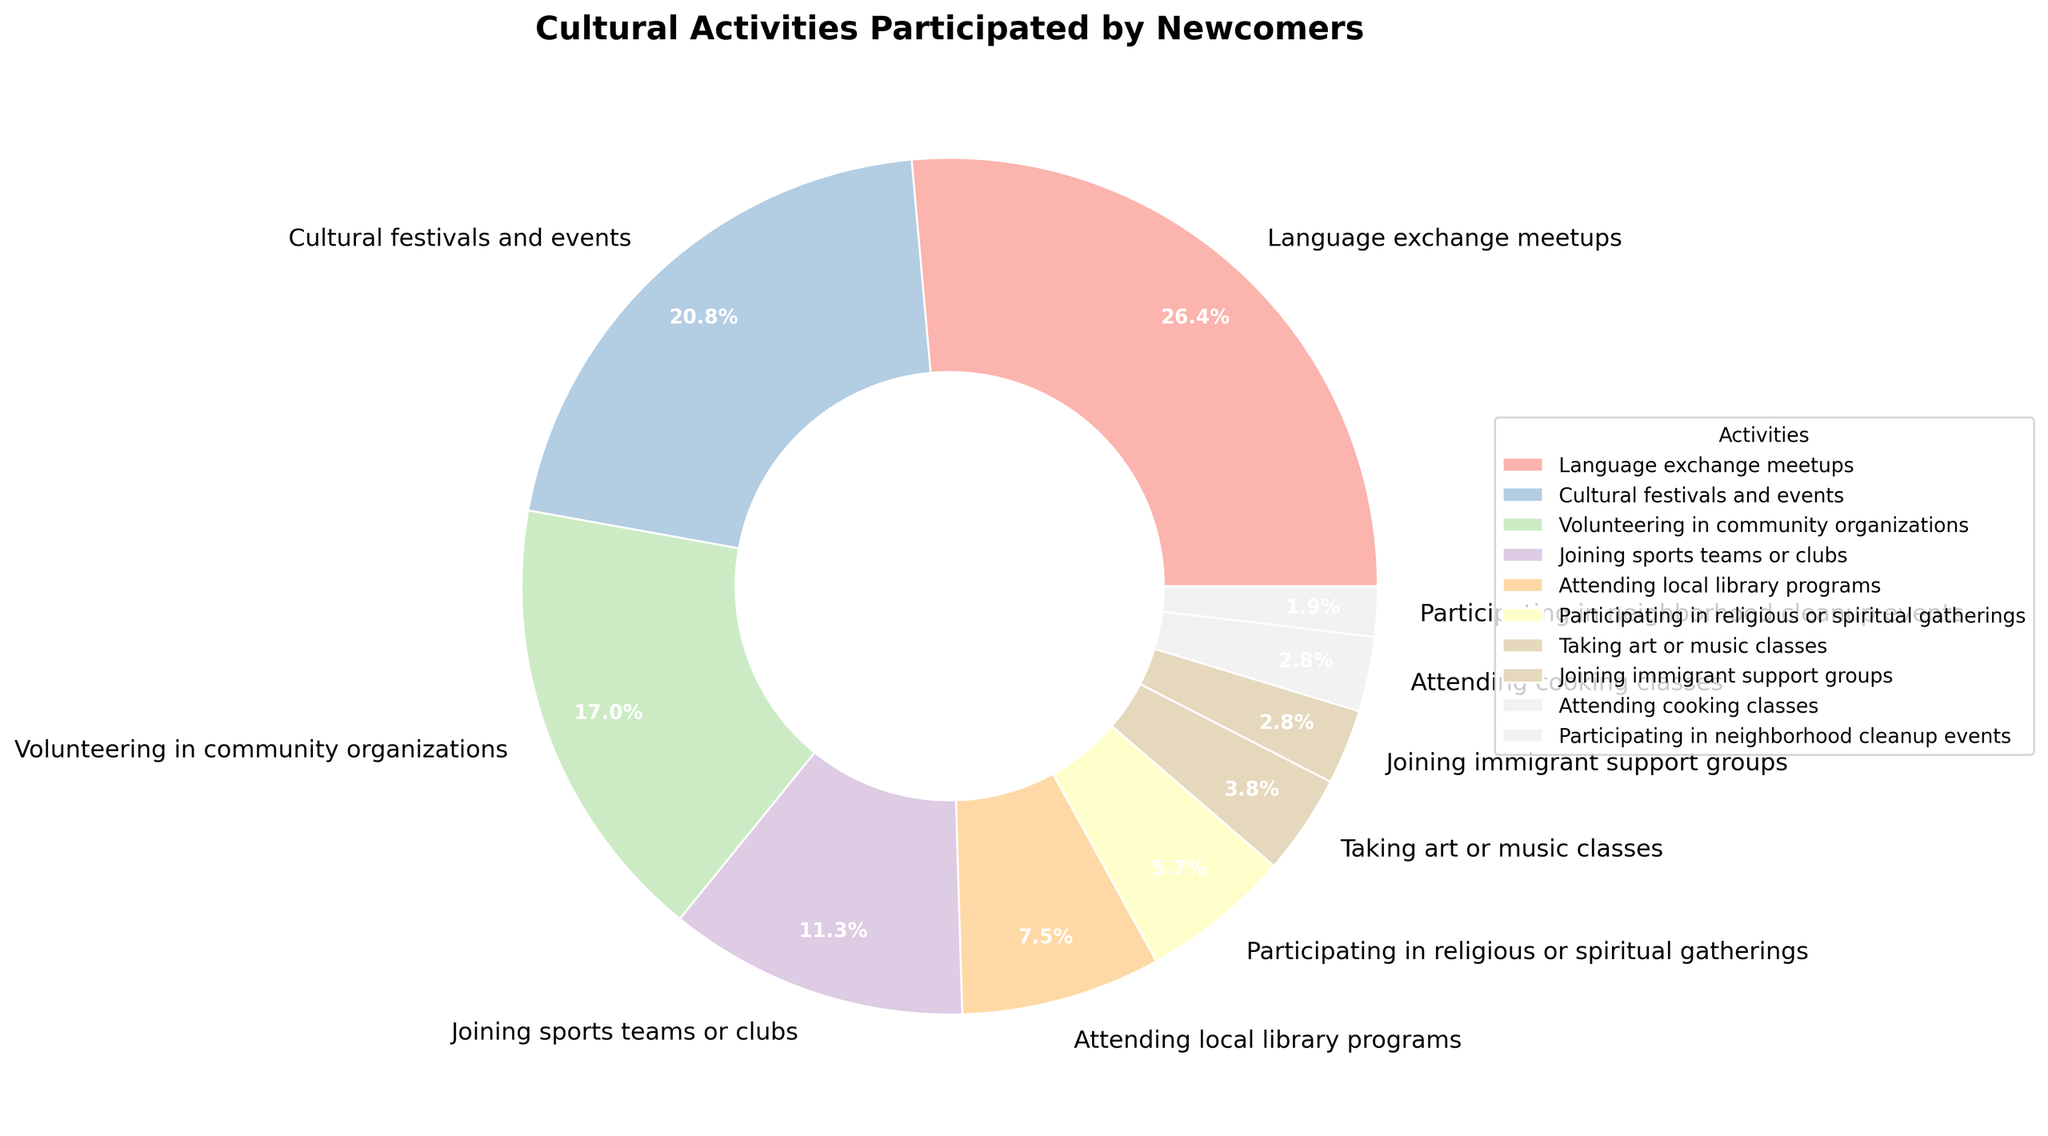Which cultural activity has the highest participation percentage? To find this, look at the slices and their corresponding labels. The largest slice represents "Language exchange meetups" with a percentage of 28%.
Answer: Language exchange meetups Which activity has the least participation? The smallest slice represents "Participating in neighborhood cleanup events" with a percentage of 2%.
Answer: Participating in neighborhood cleanup events What is the combined percentage of newcomers participating in volunteering in community organizations and joining sports teams or clubs? Summing up the percentages, we have 18% for volunteering and 12% for joining sports teams, which totals 18 + 12 = 30%.
Answer: 30% Is the percentage of newcomers attending local library programs greater than those participating in religious or spiritual gatherings? Comparing the slices, local library programs have 8%, whereas religious or spiritual gatherings have 6%. Since 8% is greater than 6%, the answer is yes.
Answer: Yes How much more popular are cultural festivals and events compared to joining immigrant support groups? Cultural festivals and events have a slice of 22%, and joining immigrant support groups has a slice of 3%. Subtracting these values, 22% - 3% = 19%.
Answer: 19% Which activity has the closest participation percentage to 5%? Looking at the slices, taking art or music classes has a percentage of 4%, which is closest to 5%.
Answer: Taking art or music classes Is the sum of the percentages for taking art or music classes and attending cooking classes greater than the percentage for joining sports teams or clubs? Taking art or music classes has a percentage of 4%, and attending cooking classes has 3%. Their sum is 4% + 3% = 7%. Joining sports teams or clubs is 12%. Since 7% is not greater than 12%, the answer is no.
Answer: No What are the three least popular activities and their combined percentage? The three smallest slices are "Participating in neighborhood cleanup events" (2%), "Joining immigrant support groups" (3%), and "Attending cooking classes" (3%). Adding them up gives 2% + 3% + 3% = 8%.
Answer: Participating in neighborhood cleanup events, Joining immigrant support groups, Attending cooking classes; 8% How does the participation percentage for language exchange meetups compare to the sum of percentages for taking art or music classes and participating in neighborhood cleanup events? Language exchange meetups have a percentage of 28%. Taking art or music classes and neighborhood cleanup events add up to 4% + 2% = 6%. Since 28% is much greater than 6%, language exchange meetups have significantly higher participation.
Answer: Language exchange meetups are much higher 